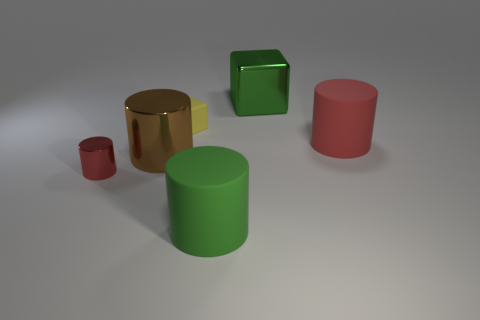How many large gray cylinders are there?
Make the answer very short. 0. How many blocks are matte objects or big brown shiny objects?
Keep it short and to the point. 1. There is a matte object to the right of the large matte thing that is to the left of the large metallic block; how many large brown metal things are to the right of it?
Make the answer very short. 0. What color is the metal cube that is the same size as the green cylinder?
Provide a succinct answer. Green. How many other things are there of the same color as the tiny cube?
Offer a terse response. 0. Are there more large brown cylinders right of the large green cylinder than big green objects?
Provide a succinct answer. No. Is the material of the big green block the same as the large brown thing?
Your answer should be very brief. Yes. How many objects are either big cylinders behind the small red metallic cylinder or blue rubber objects?
Make the answer very short. 2. What number of other things are there of the same size as the red shiny thing?
Your response must be concise. 1. Are there an equal number of brown metallic objects that are in front of the red shiny object and brown cylinders in front of the green matte cylinder?
Give a very brief answer. Yes. 